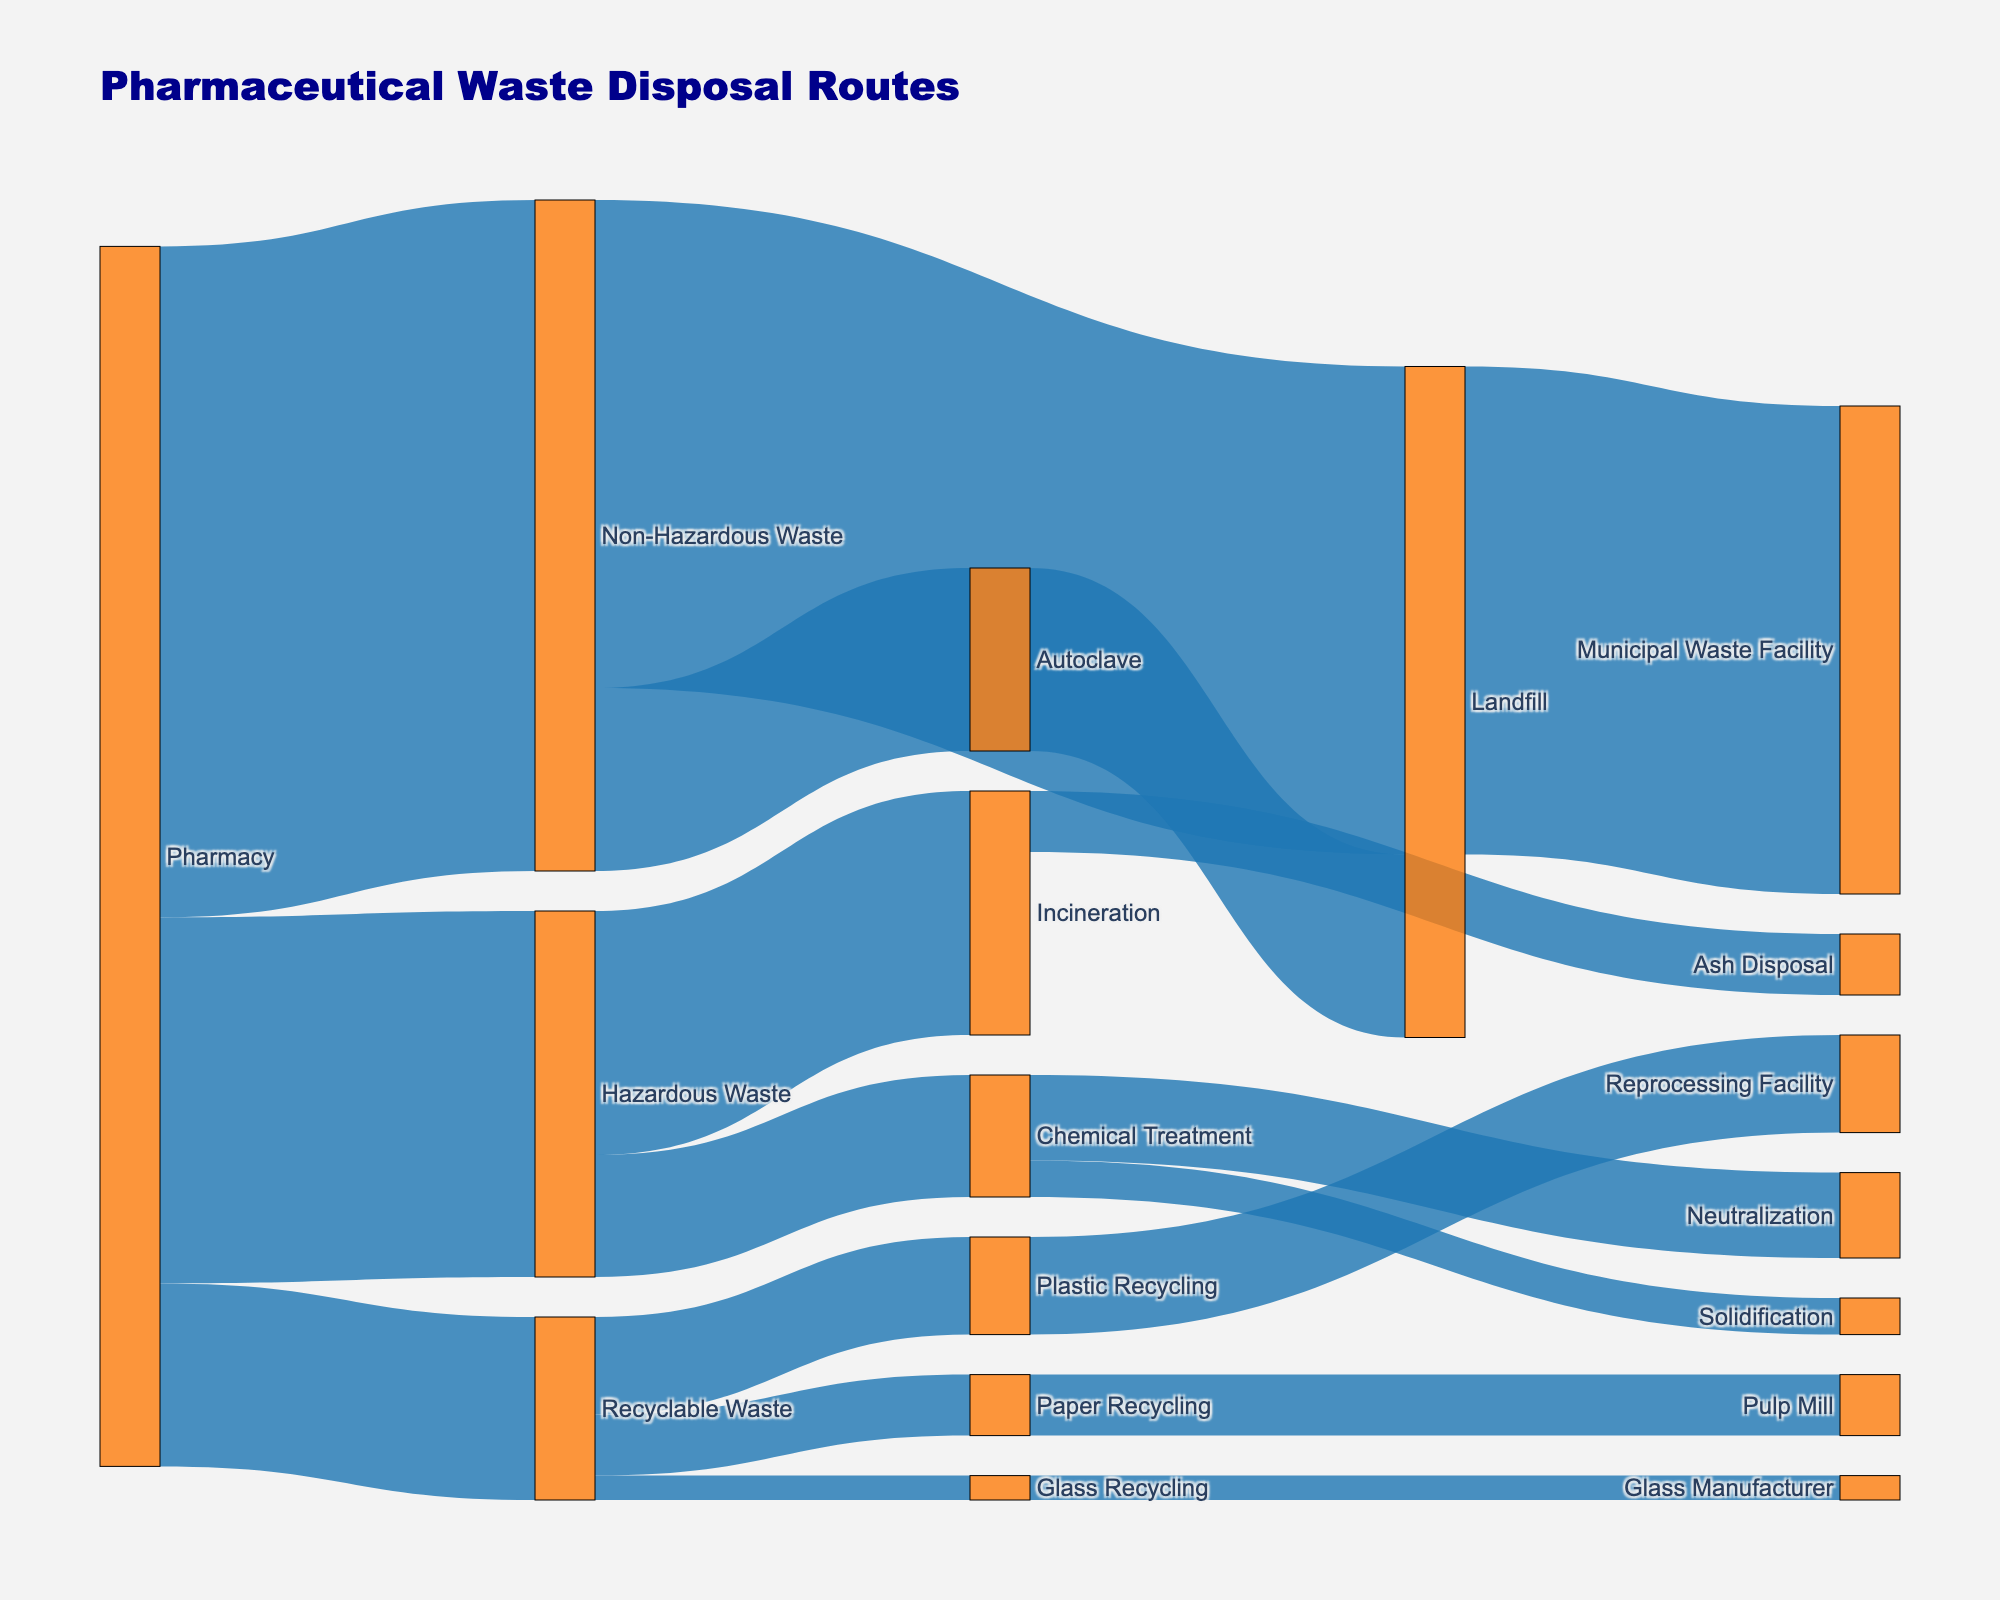What is the title of the Sankey diagram? The title is typically found at the top of the diagram and describes the overall content. In this case, the title is "Pharmaceutical Waste Disposal Routes".
Answer: Pharmaceutical Waste Disposal Routes What are the three types of waste generated by the pharmacy? To identify the types of waste, you need to look at the nodes directly connected to the "Pharmacy" node. The three types are "Hazardous Waste", "Non-Hazardous Waste", and "Recyclable Waste".
Answer: Hazardous Waste, Non-Hazardous Waste, Recyclable Waste How much total waste is produced by the pharmacy? To find this, sum the values of all outgoing flows from the "Pharmacy" node. These values are 30 (Hazardous Waste), 55 (Non-Hazardous Waste), and 15 (Recyclable Waste). The total is 30 + 55 + 15 = 100.
Answer: 100 Which waste disposal method handles the most hazardous waste? Look at the outgoing flows from the "Hazardous Waste" node. The values are 20 for "Incineration" and 10 for "Chemical Treatment". Incineration handles more with 20.
Answer: Incineration Which recycling category receives the least amount of recyclable waste? Look at the outgoing flows from the "Recyclable Waste" node. The values are 8 (Plastic Recycling), 5 (Paper Recycling), and 2 (Glass Recycling). Glass Recycling receives the least with 2.
Answer: Glass Recycling What is the end destination for non-hazardous waste processed in an autoclave? Trace the flow from the "Autoclave" node. All of it (15) goes to "Landfill".
Answer: Landfill What is the combined quantity of waste treated through chemical methods? Sum the values of all outgoing flows from the "Chemical Treatment" node. These values are 7 (Neutralization) and 3 (Solidification). The total is 7 + 3 = 10.
Answer: 10 How does the amount of non-hazardous waste directed to a landfill compare with the municipal waste facility's capacity? The flow from "Non-Hazardous Waste" to "Landfill" is 40. This matches the capacity of the "Municipal Waste Facility" which also receives 40. Therefore, the amounts are equal.
Answer: Equal Which route has the smallest flow of waste? To find the smallest value, look through all the links in the diagram. The smallest flow of waste is 2, which goes from "Recyclable Waste" to "Glass Recycling" and from "Glass Recycling" to "Glass Manufacturer".
Answer: Recyclable Waste to Glass Recycling What kind of treatment is used for hazardous waste besides incineration? Look at the paths coming out from "Hazardous Waste". Aside from "Incineration" (20), "Chemical Treatment" (10) is used.
Answer: Chemical Treatment 